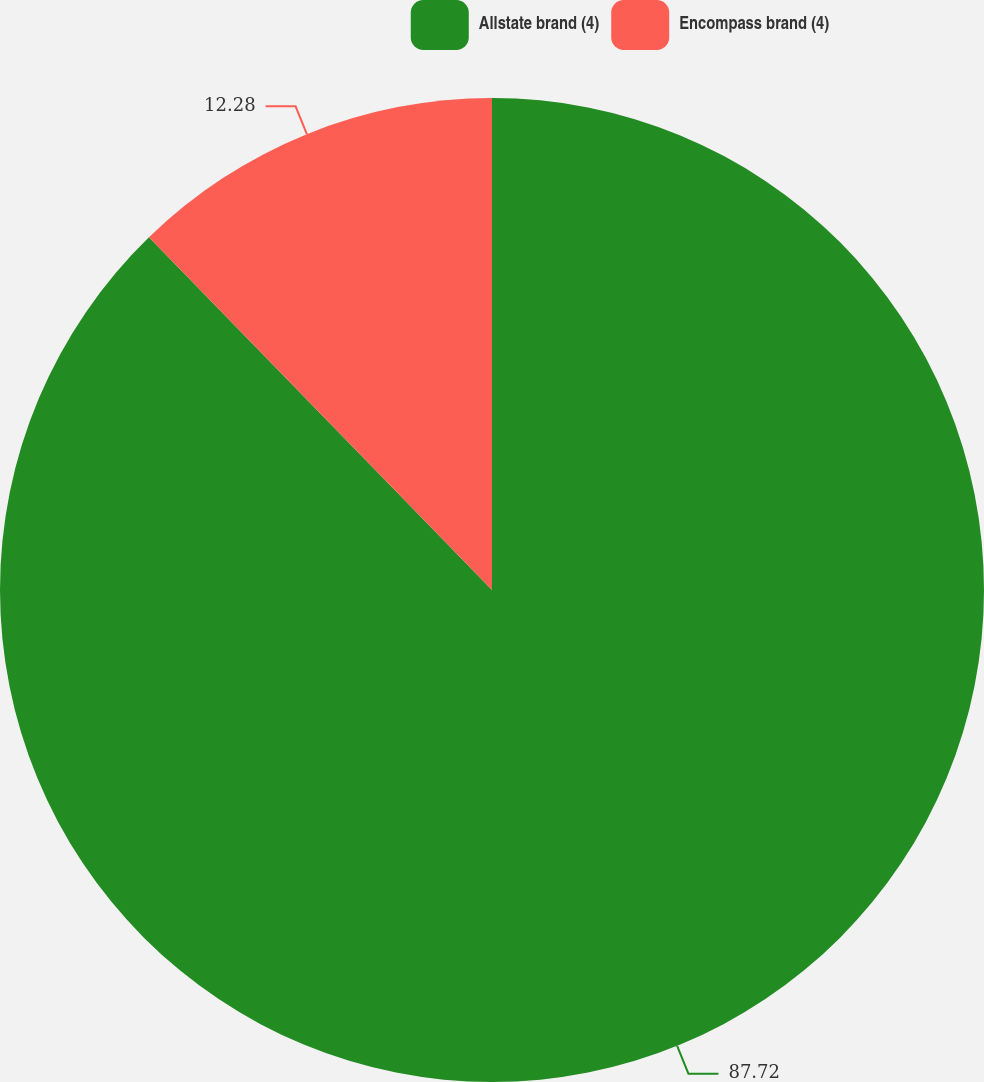Convert chart. <chart><loc_0><loc_0><loc_500><loc_500><pie_chart><fcel>Allstate brand (4)<fcel>Encompass brand (4)<nl><fcel>87.72%<fcel>12.28%<nl></chart> 